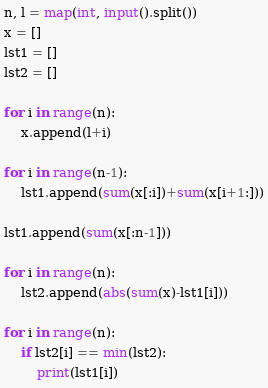<code> <loc_0><loc_0><loc_500><loc_500><_Python_>n, l = map(int, input().split())
x = []          
lst1 = []
lst2 = []                

for i in range(n):
    x.append(l+i)

for i in range(n-1):
    lst1.append(sum(x[:i])+sum(x[i+1:]))

lst1.append(sum(x[:n-1]))

for i in range(n):
    lst2.append(abs(sum(x)-lst1[i]))

for i in range(n):
    if lst2[i] == min(lst2):
        print(lst1[i])</code> 